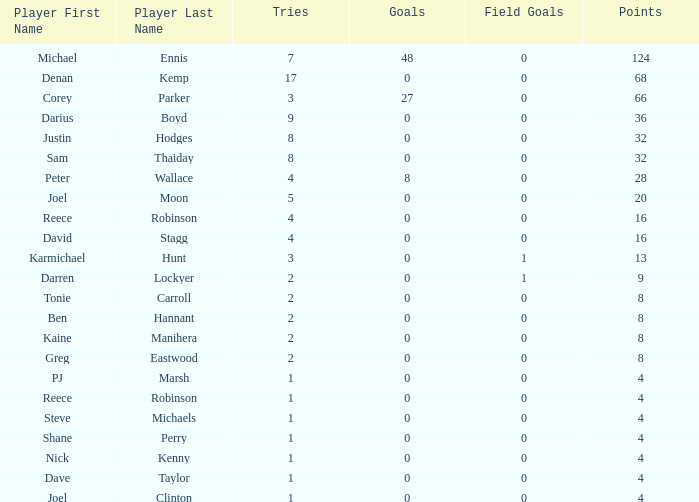Give me the full table as a dictionary. {'header': ['Player First Name', 'Player Last Name', 'Tries', 'Goals', 'Field Goals', 'Points'], 'rows': [['Michael', 'Ennis', '7', '48', '0', '124'], ['Denan', 'Kemp', '17', '0', '0', '68'], ['Corey', 'Parker', '3', '27', '0', '66'], ['Darius', 'Boyd', '9', '0', '0', '36'], ['Justin', 'Hodges', '8', '0', '0', '32'], ['Sam', 'Thaiday', '8', '0', '0', '32'], ['Peter', 'Wallace', '4', '8', '0', '28'], ['Joel', 'Moon', '5', '0', '0', '20'], ['Reece', 'Robinson', '4', '0', '0', '16'], ['David', 'Stagg', '4', '0', '0', '16'], ['Karmichael', 'Hunt', '3', '0', '1', '13'], ['Darren', 'Lockyer', '2', '0', '1', '9'], ['Tonie', 'Carroll', '2', '0', '0', '8'], ['Ben', 'Hannant', '2', '0', '0', '8'], ['Kaine', 'Manihera', '2', '0', '0', '8'], ['Greg', 'Eastwood', '2', '0', '0', '8'], ['PJ', 'Marsh', '1', '0', '0', '4'], ['Reece', 'Robinson', '1', '0', '0', '4'], ['Steve', 'Michaels', '1', '0', '0', '4'], ['Shane', 'Perry', '1', '0', '0', '4'], ['Nick', 'Kenny', '1', '0', '0', '4'], ['Dave', 'Taylor', '1', '0', '0', '4'], ['Joel', 'Clinton', '1', '0', '0', '4']]} How many goals did the player with less than 4 points have? 0.0. 